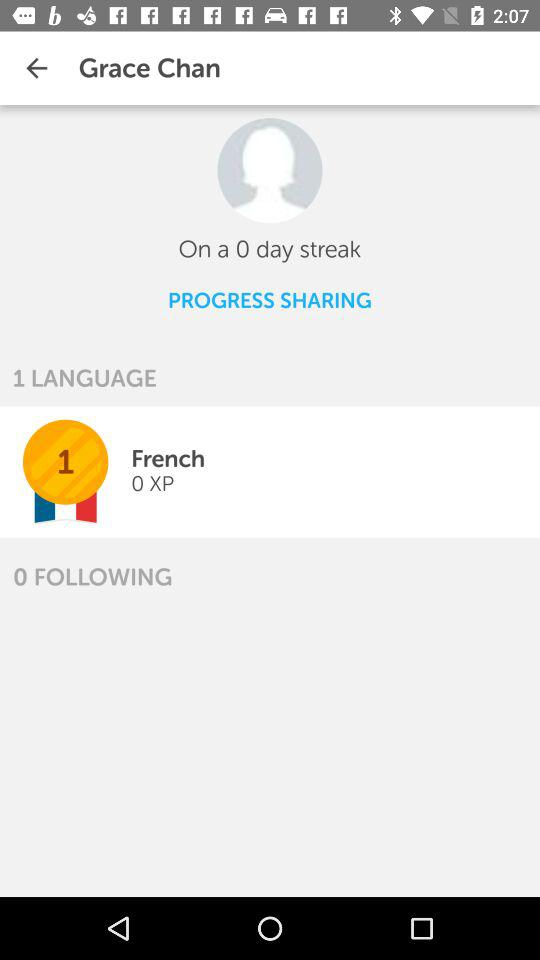What number of people is Grace Chan following? Grace Chan is following 0 people. 